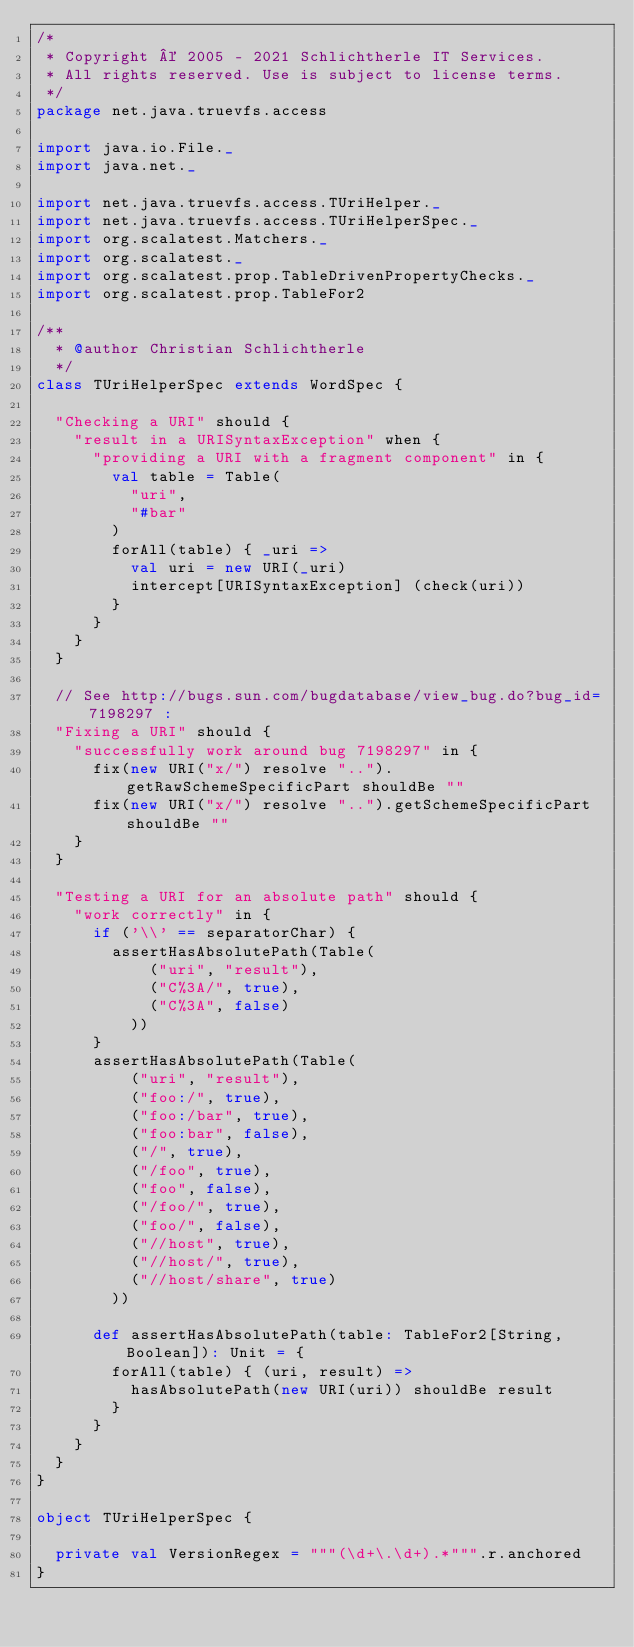<code> <loc_0><loc_0><loc_500><loc_500><_Scala_>/*
 * Copyright © 2005 - 2021 Schlichtherle IT Services.
 * All rights reserved. Use is subject to license terms.
 */
package net.java.truevfs.access

import java.io.File._
import java.net._

import net.java.truevfs.access.TUriHelper._
import net.java.truevfs.access.TUriHelperSpec._
import org.scalatest.Matchers._
import org.scalatest._
import org.scalatest.prop.TableDrivenPropertyChecks._
import org.scalatest.prop.TableFor2

/**
  * @author Christian Schlichtherle
  */
class TUriHelperSpec extends WordSpec {

  "Checking a URI" should {
    "result in a URISyntaxException" when {
      "providing a URI with a fragment component" in {
        val table = Table(
          "uri",
          "#bar"
        )
        forAll(table) { _uri =>
          val uri = new URI(_uri)
          intercept[URISyntaxException] (check(uri))
        }
      }
    }
  }

  // See http://bugs.sun.com/bugdatabase/view_bug.do?bug_id=7198297 :
  "Fixing a URI" should {
    "successfully work around bug 7198297" in {
      fix(new URI("x/") resolve "..").getRawSchemeSpecificPart shouldBe ""
      fix(new URI("x/") resolve "..").getSchemeSpecificPart shouldBe ""
    }
  }

  "Testing a URI for an absolute path" should {
    "work correctly" in {
      if ('\\' == separatorChar) {
        assertHasAbsolutePath(Table(
            ("uri", "result"),
            ("C%3A/", true),
            ("C%3A", false)
          ))
      }
      assertHasAbsolutePath(Table(
          ("uri", "result"),
          ("foo:/", true),
          ("foo:/bar", true),
          ("foo:bar", false),
          ("/", true),
          ("/foo", true),
          ("foo", false),
          ("/foo/", true),
          ("foo/", false),
          ("//host", true),
          ("//host/", true),
          ("//host/share", true)
        ))

      def assertHasAbsolutePath(table: TableFor2[String, Boolean]): Unit = {
        forAll(table) { (uri, result) =>
          hasAbsolutePath(new URI(uri)) shouldBe result
        }
      }
    }
  }
}

object TUriHelperSpec {

  private val VersionRegex = """(\d+\.\d+).*""".r.anchored
}</code> 